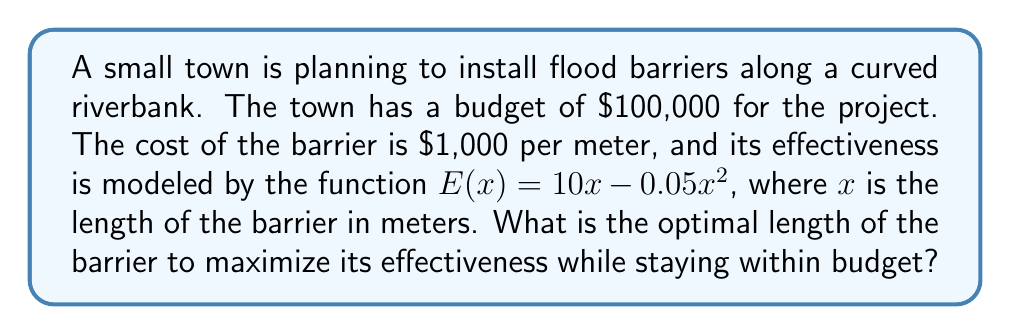Provide a solution to this math problem. To solve this problem, we'll use nonlinear programming methods:

1) First, let's define our objective function and constraint:
   Maximize: $E(x) = 10x - 0.05x^2$
   Subject to: $1000x \leq 100000$ (budget constraint)

2) The budget constraint simplifies to $x \leq 100$

3) To find the maximum of $E(x)$, we differentiate and set it to zero:
   $$\frac{dE}{dx} = 10 - 0.1x = 0$$

4) Solving this equation:
   $10 - 0.1x = 0$
   $0.1x = 10$
   $x = 100$

5) This critical point ($x = 100$) coincides with our budget constraint, which is good.

6) To confirm it's a maximum, we check the second derivative:
   $$\frac{d^2E}{dx^2} = -0.1 < 0$$
   This confirms we have a maximum at $x = 100$.

7) Therefore, the optimal length is 100 meters, which uses the entire budget and maximizes effectiveness.

8) The maximum effectiveness is:
   $E(100) = 10(100) - 0.05(100)^2 = 1000 - 500 = 500$
Answer: 100 meters 